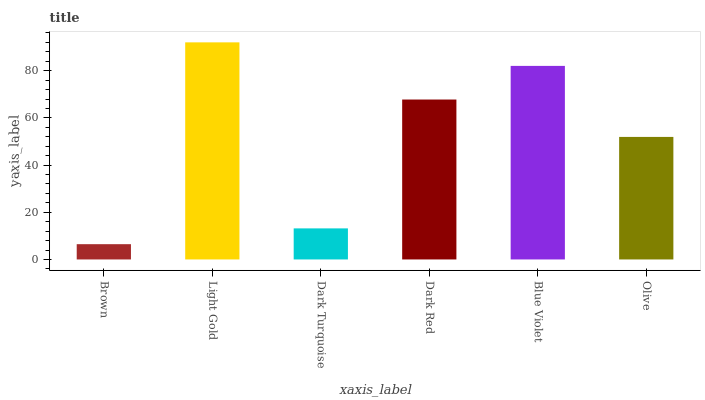Is Brown the minimum?
Answer yes or no. Yes. Is Light Gold the maximum?
Answer yes or no. Yes. Is Dark Turquoise the minimum?
Answer yes or no. No. Is Dark Turquoise the maximum?
Answer yes or no. No. Is Light Gold greater than Dark Turquoise?
Answer yes or no. Yes. Is Dark Turquoise less than Light Gold?
Answer yes or no. Yes. Is Dark Turquoise greater than Light Gold?
Answer yes or no. No. Is Light Gold less than Dark Turquoise?
Answer yes or no. No. Is Dark Red the high median?
Answer yes or no. Yes. Is Olive the low median?
Answer yes or no. Yes. Is Olive the high median?
Answer yes or no. No. Is Dark Red the low median?
Answer yes or no. No. 